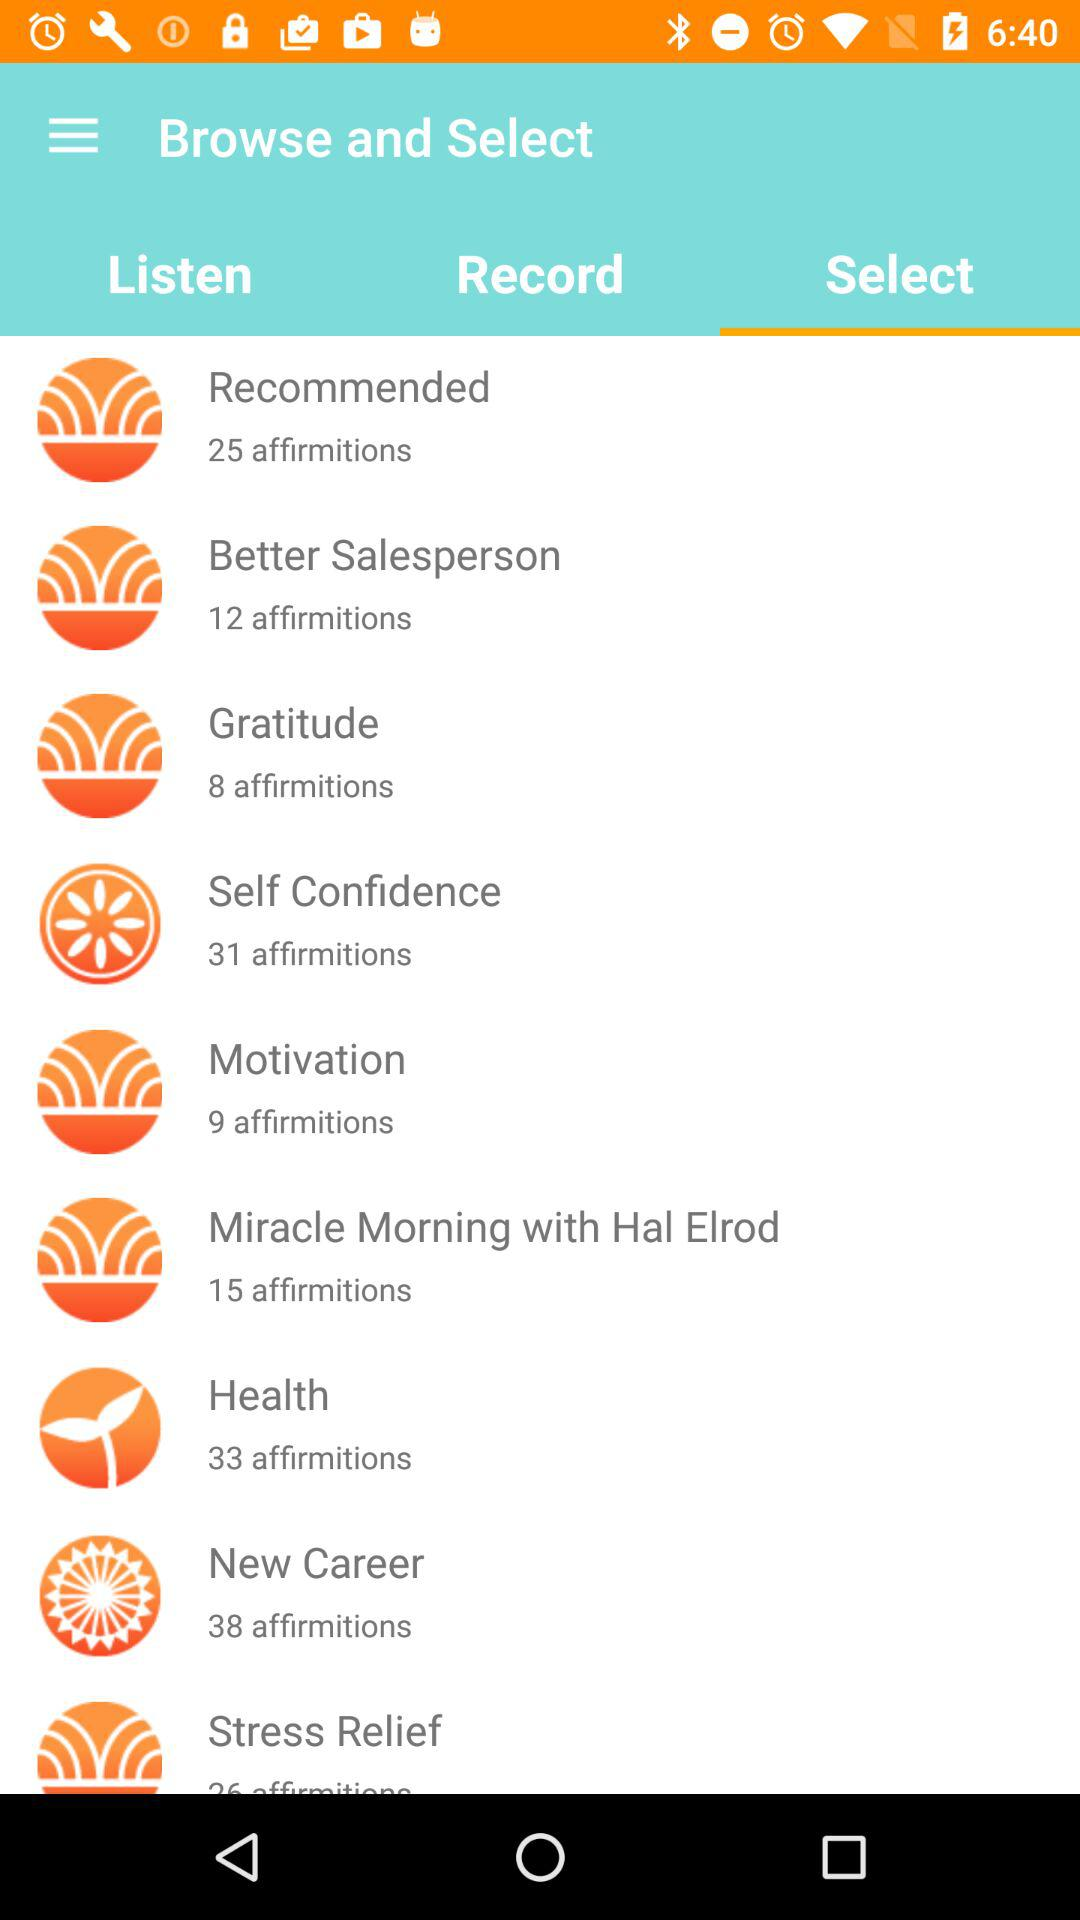How many affirmations are in the Health category?
Answer the question using a single word or phrase. 33 